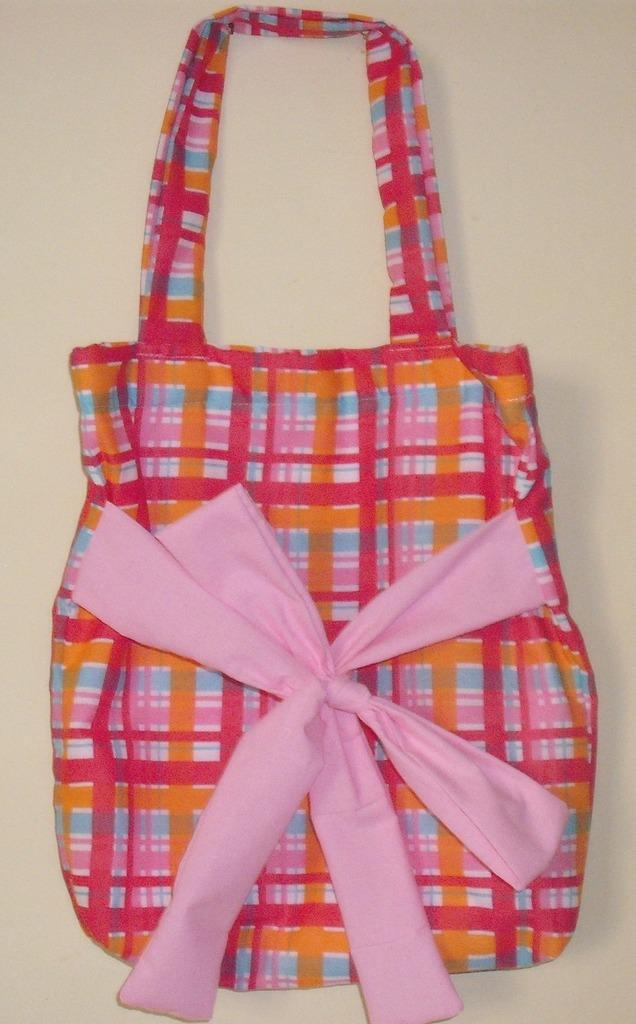What type of bag is in the image? There is a mixed color bag in the image. How is the bag described? The bag is described as beautiful. What color is the ribbon attached to the bag? There is a pink color ribbon attached to the bag. What type of lettuce is visible in the image? There is no lettuce present in the image. 